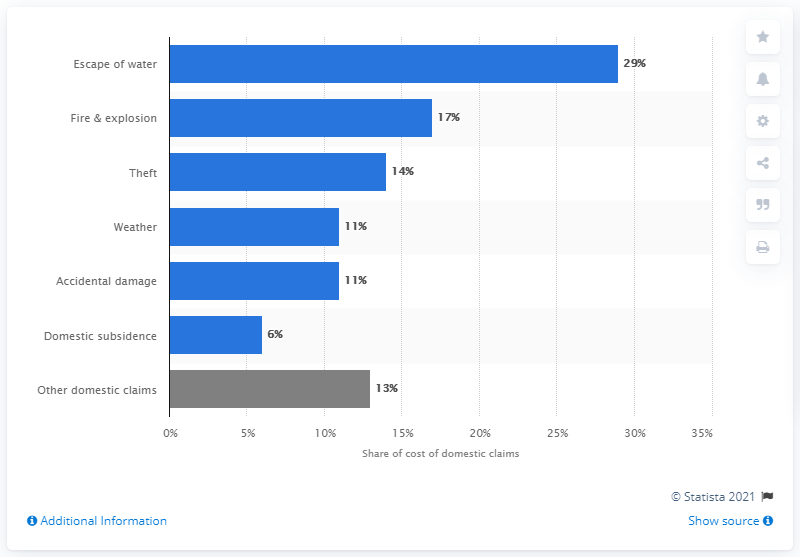Point out several critical features in this image. In the UK in 2019, approximately 29% of all insurance claims were caused by the escape of water. 